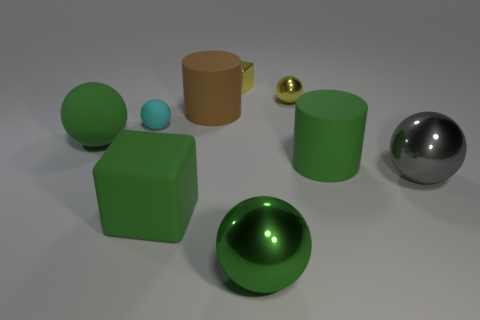What is the color of the small sphere on the right side of the matte block that is in front of the tiny rubber sphere? The small sphere situated on the right side of the matte green block, which is in front of the tiny rubber sphere, boasts a vibrant yellow color. It contrasts pleasantly with the varying shades and textures of the objects around it. 